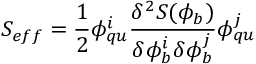Convert formula to latex. <formula><loc_0><loc_0><loc_500><loc_500>S _ { e f f } = \frac { 1 } { 2 } \phi _ { q u } ^ { i } \frac { \delta ^ { 2 } S ( \phi _ { b } ) } { \delta \phi _ { b } ^ { i } \delta \phi _ { b } ^ { j } } \phi _ { q u } ^ { j }</formula> 